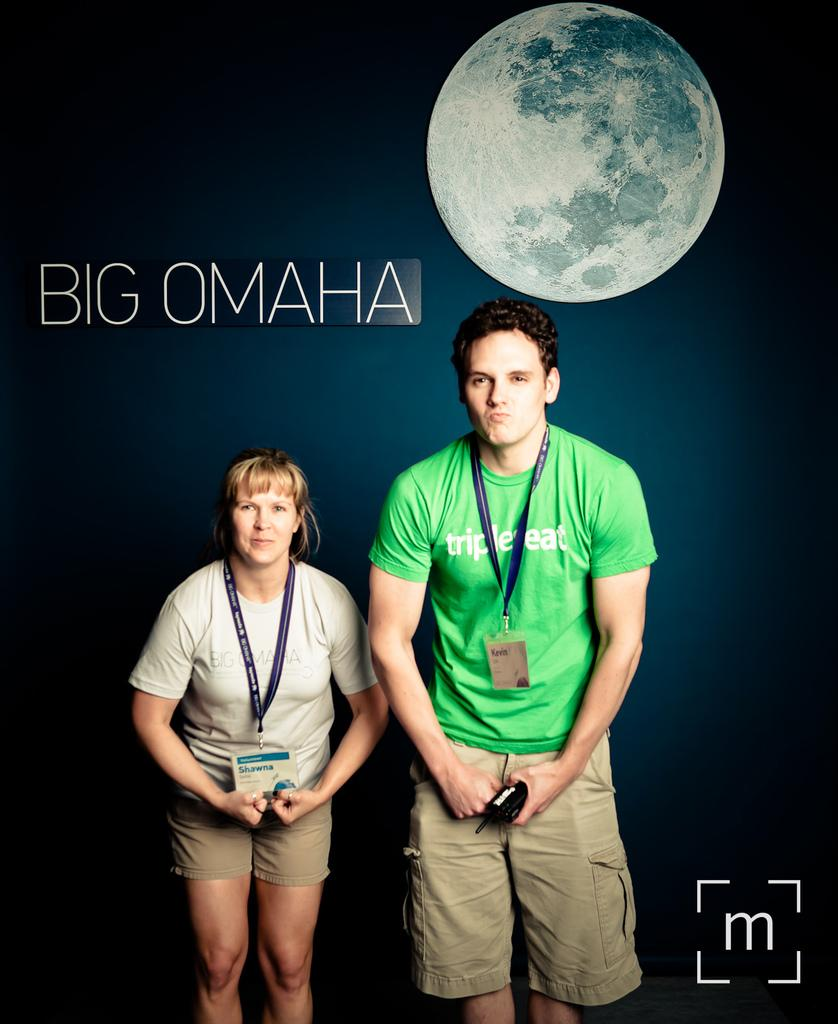How many people are in the image? There are two persons standing in the image. What are the persons holding in the image? The persons are holding an object. What can be seen in the background of the image? There is a picture of a moon in the background. What is written or depicted in the image? There is text in the image. Where is the logo located in the image? There is a logo in the bottom right corner of the image. How many sheep are visible in the image? There are no sheep present in the image. What angle is the book being held at in the image? There is no book present in the image. 